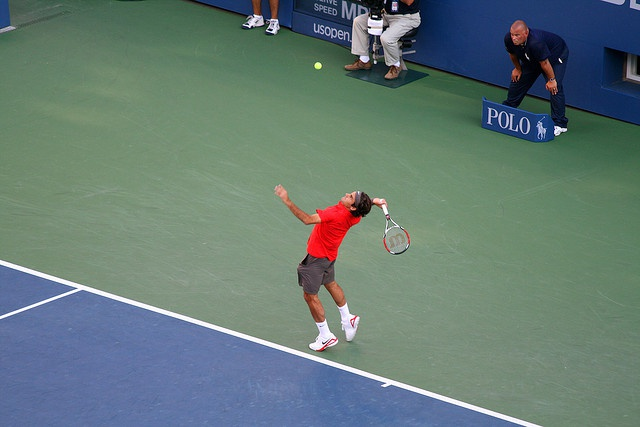Describe the objects in this image and their specific colors. I can see people in darkblue, red, gray, lavender, and darkgray tones, people in darkblue, black, navy, brown, and maroon tones, people in darkblue, darkgray, black, lavender, and gray tones, tennis racket in darkblue, darkgray, gray, and white tones, and people in darkblue, maroon, lavender, black, and darkgray tones in this image. 